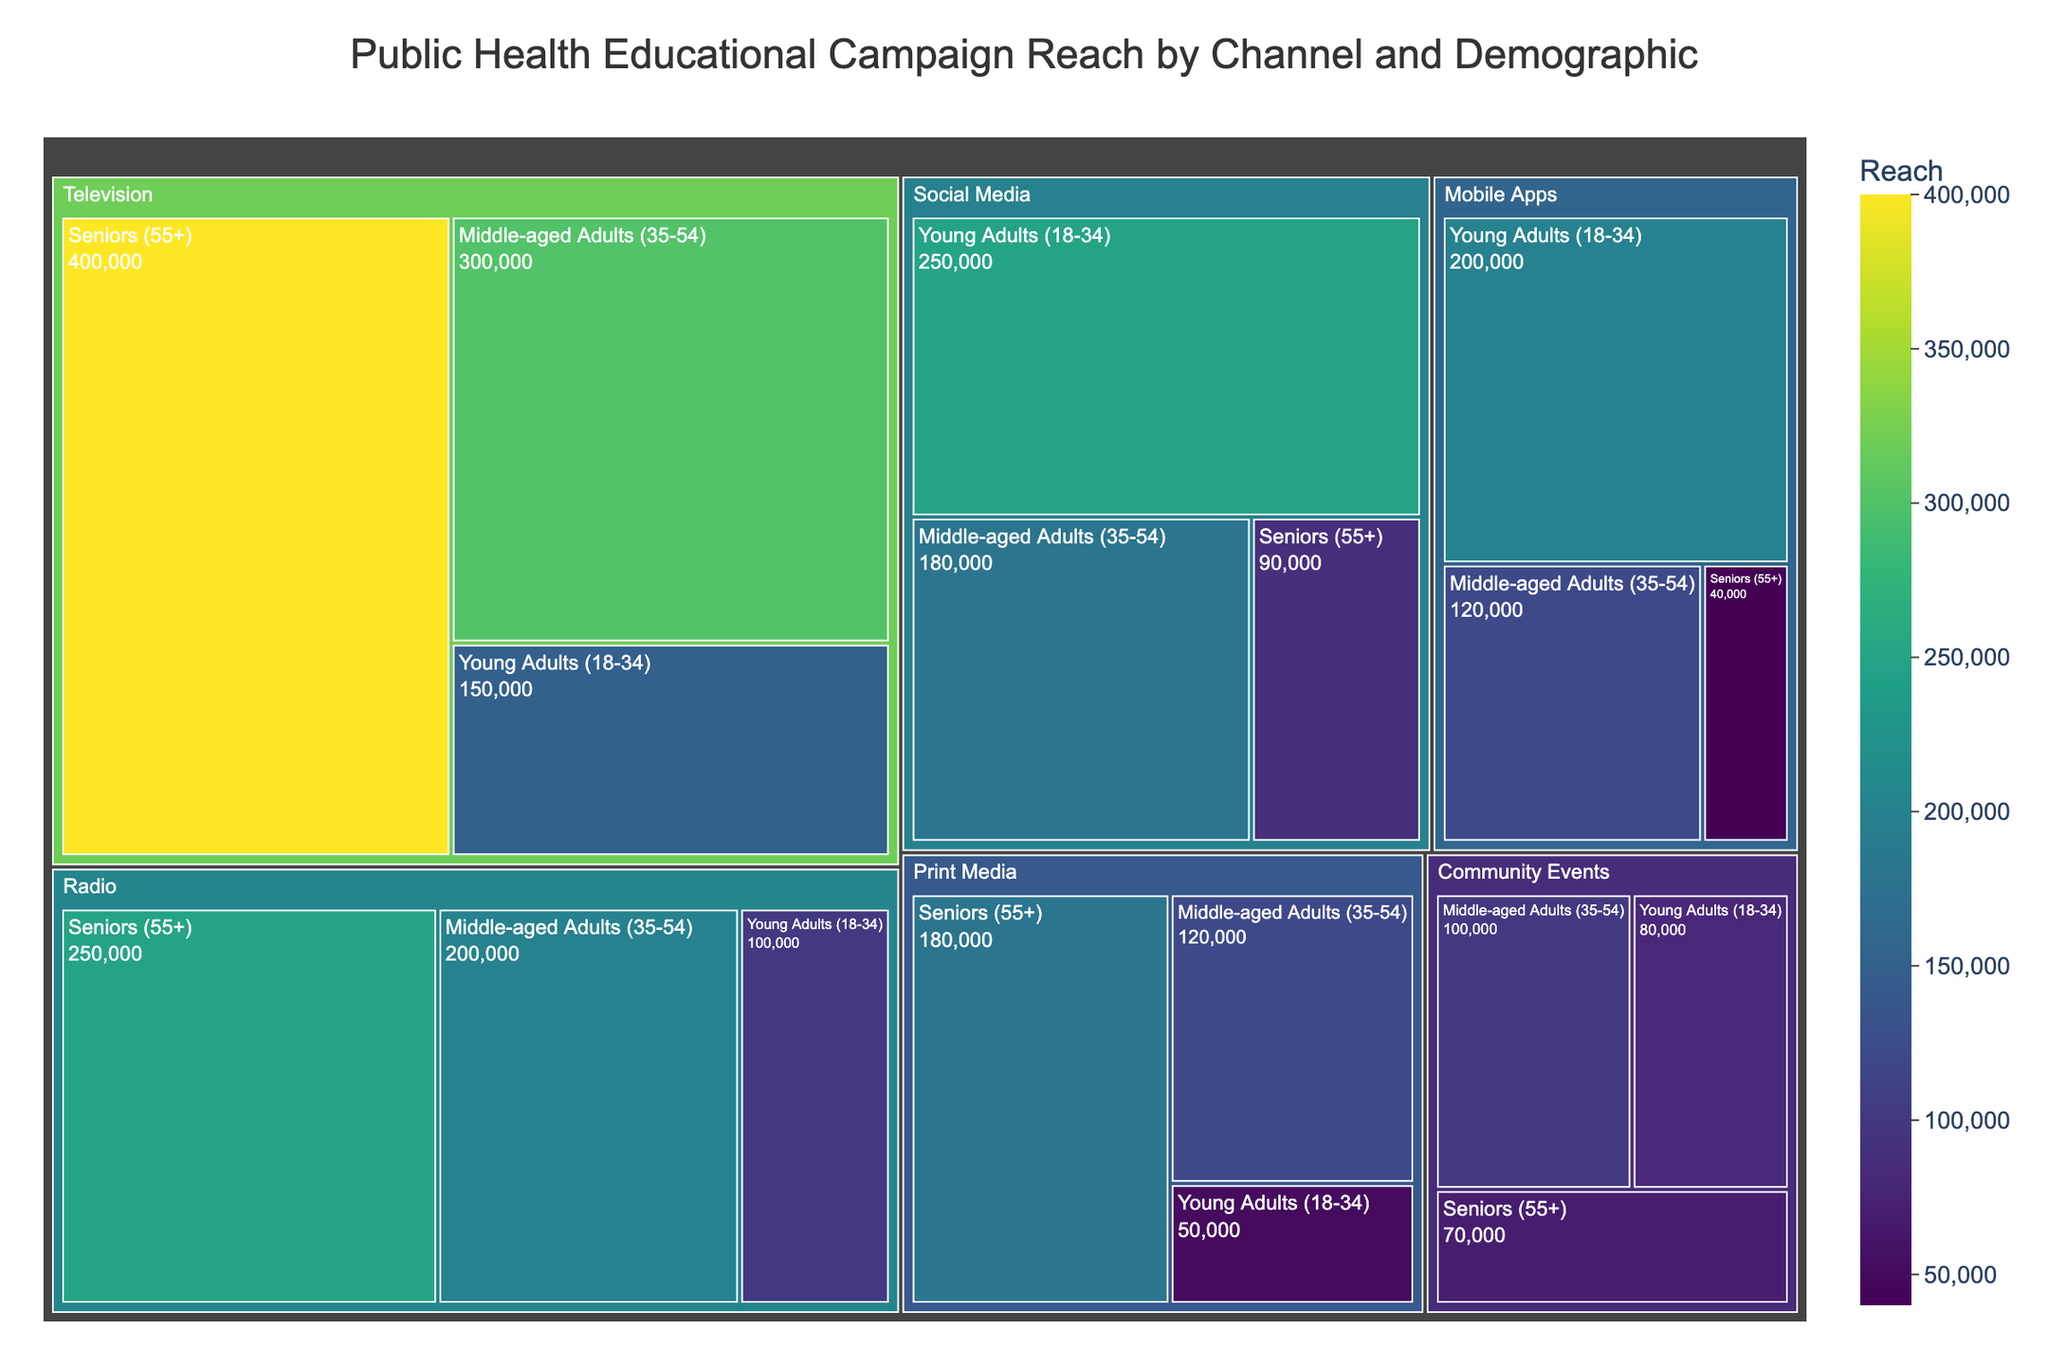What is the title of the figure? The title is typically displayed at the top of the figure. By referring to the title text, we can identify it.
Answer: Public Health Educational Campaign Reach by Channel and Demographic Which demographic has the highest reach through Television? Look at the Television section in the treemap and identify the demographic group with the largest area or highest value labeled.
Answer: Seniors (55+) Which channel has the lowest reach among Seniors (55+)? In the treemap, find the sections representing different channels for the Seniors demographic. Identify the one with the smallest area or lowest value.
Answer: Mobile Apps What is the total reach of the Public Health Educational Campaign through Social Media? Sum the reach values for all demographic groups under Social Media in the treemap.
Answer: 520,000 How does the reach of Radio compare between Middle-aged Adults (35-54) and Seniors (55+)? Identify the reach values for both groups under Radio in the treemap and compare them.
Answer: Seniors (55+) have a higher reach Which demographic group has the highest total reach across all channels? Sum the reach values for each demographic group across all channels in the treemap and identify the group with the highest total.
Answer: Seniors (55+) How does the reach of Mobile Apps for Young Adults (18-34) compare to the reach of Community Events for the same demographic? Identify the reach values for both Mobile Apps and Community Events under the Young Adults demographic in the treemap and compare them.
Answer: Mobile Apps have a higher reach What is the difference in reach between Print Media and Social Media for Middle-aged Adults (35-54)? Identify the reach values for Print Media and Social Media under the Middle-aged Adults demographic in the treemap and calculate the difference.
Answer: 60,000 Which communication channel has the broadest reach across all demographics? Sum the reach values for each channel across all demographics in the treemap and identify the channel with the highest total.
Answer: Television 